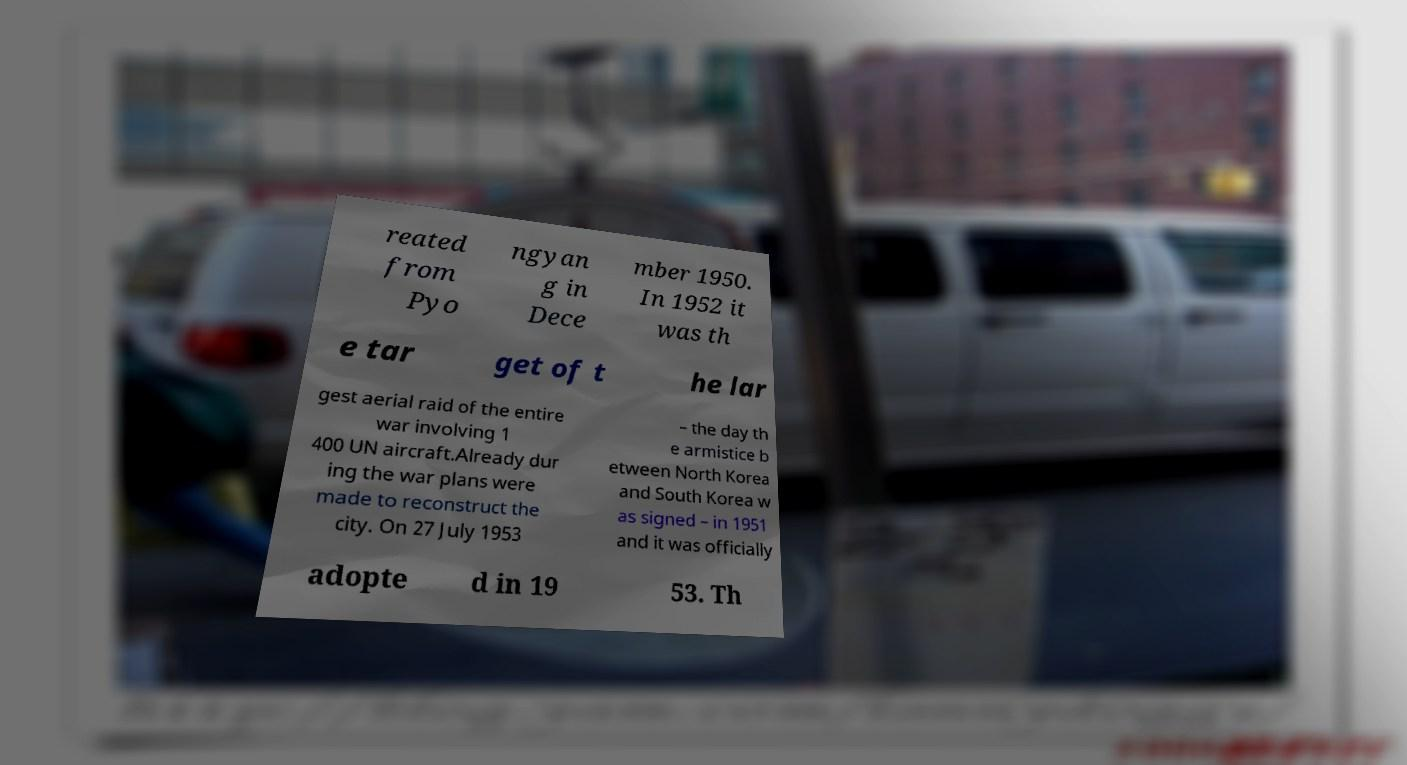Can you read and provide the text displayed in the image?This photo seems to have some interesting text. Can you extract and type it out for me? reated from Pyo ngyan g in Dece mber 1950. In 1952 it was th e tar get of t he lar gest aerial raid of the entire war involving 1 400 UN aircraft.Already dur ing the war plans were made to reconstruct the city. On 27 July 1953 – the day th e armistice b etween North Korea and South Korea w as signed – in 1951 and it was officially adopte d in 19 53. Th 